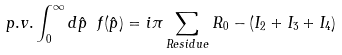<formula> <loc_0><loc_0><loc_500><loc_500>p . v . \int _ { 0 } ^ { \infty } d \hat { p } \ f ( \hat { p } ) = i \pi \sum _ { R e s i d u e } R _ { 0 } - ( I _ { 2 } + I _ { 3 } + I _ { 4 } )</formula> 